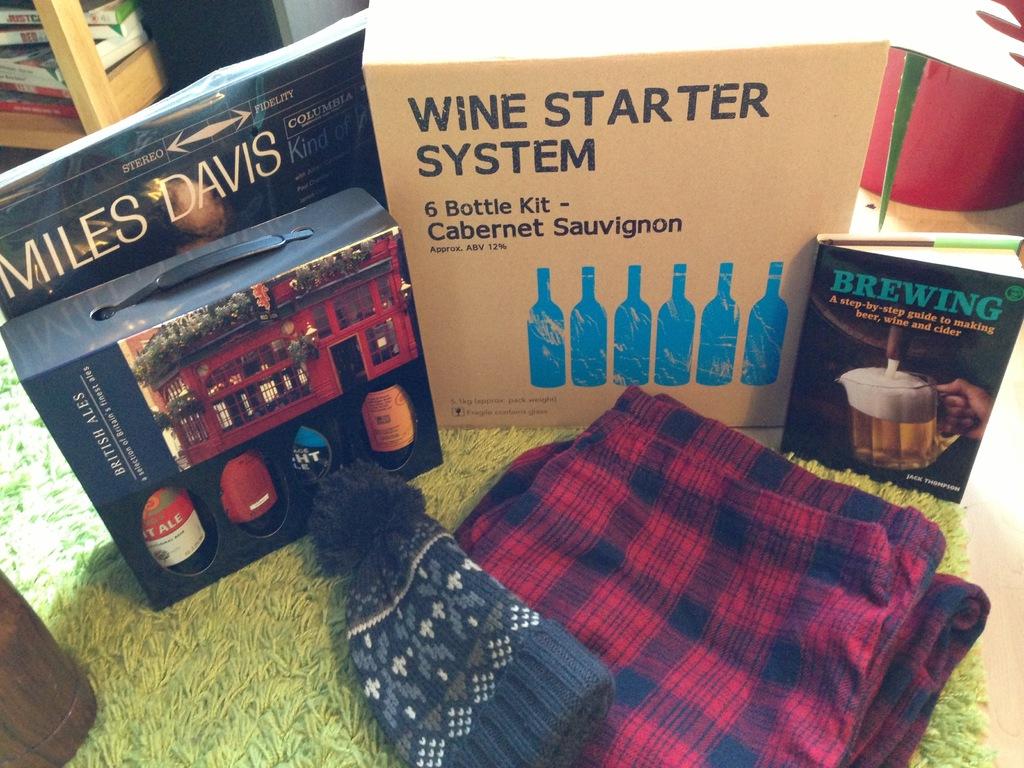What kind of system is mentioned on the box in the middle?
Your answer should be compact. Wine starter. How many bottles of cabernet sauvignon are in the starter kit?
Give a very brief answer. 6. 